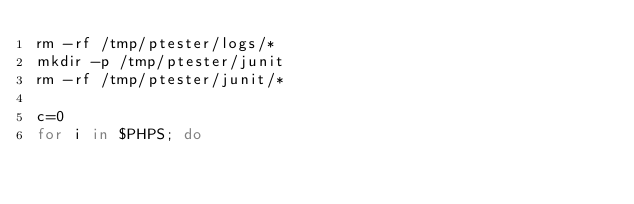Convert code to text. <code><loc_0><loc_0><loc_500><loc_500><_Bash_>rm -rf /tmp/ptester/logs/*
mkdir -p /tmp/ptester/junit
rm -rf /tmp/ptester/junit/*

c=0
for i in $PHPS; do</code> 